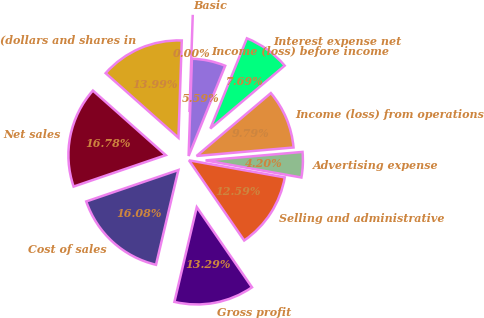<chart> <loc_0><loc_0><loc_500><loc_500><pie_chart><fcel>(dollars and shares in<fcel>Net sales<fcel>Cost of sales<fcel>Gross profit<fcel>Selling and administrative<fcel>Advertising expense<fcel>Income (loss) from operations<fcel>Interest expense net<fcel>Income (loss) before income<fcel>Basic<nl><fcel>13.99%<fcel>16.78%<fcel>16.08%<fcel>13.29%<fcel>12.59%<fcel>4.2%<fcel>9.79%<fcel>7.69%<fcel>5.59%<fcel>0.0%<nl></chart> 